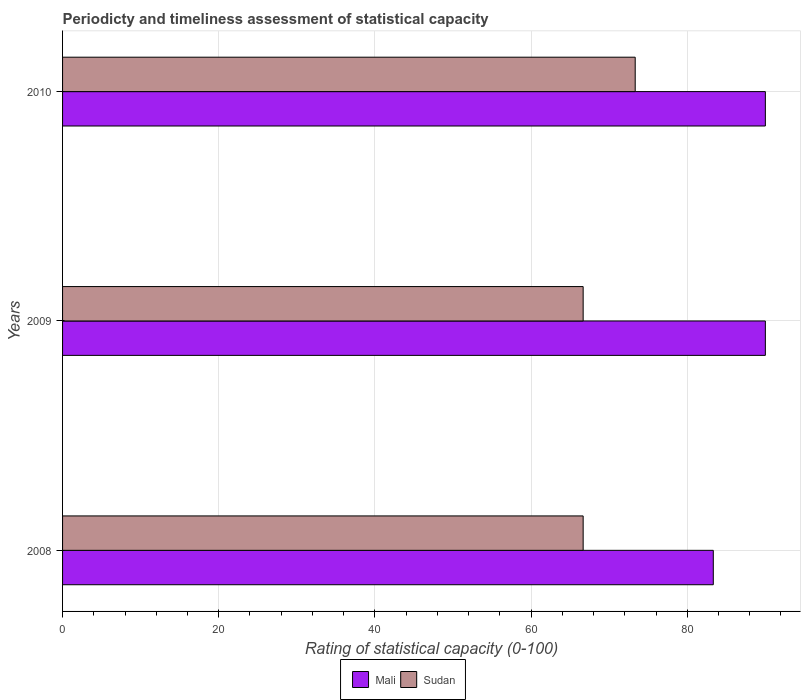How many different coloured bars are there?
Provide a succinct answer. 2. How many groups of bars are there?
Your response must be concise. 3. Are the number of bars per tick equal to the number of legend labels?
Your answer should be very brief. Yes. How many bars are there on the 3rd tick from the top?
Provide a succinct answer. 2. How many bars are there on the 2nd tick from the bottom?
Your response must be concise. 2. What is the label of the 3rd group of bars from the top?
Your response must be concise. 2008. What is the rating of statistical capacity in Sudan in 2010?
Ensure brevity in your answer.  73.33. Across all years, what is the maximum rating of statistical capacity in Sudan?
Ensure brevity in your answer.  73.33. Across all years, what is the minimum rating of statistical capacity in Mali?
Give a very brief answer. 83.33. In which year was the rating of statistical capacity in Sudan maximum?
Your response must be concise. 2010. What is the total rating of statistical capacity in Sudan in the graph?
Make the answer very short. 206.67. What is the difference between the rating of statistical capacity in Sudan in 2008 and that in 2009?
Offer a terse response. 0. What is the difference between the rating of statistical capacity in Mali in 2010 and the rating of statistical capacity in Sudan in 2008?
Provide a short and direct response. 23.33. What is the average rating of statistical capacity in Mali per year?
Keep it short and to the point. 87.78. In the year 2008, what is the difference between the rating of statistical capacity in Sudan and rating of statistical capacity in Mali?
Give a very brief answer. -16.67. Is the rating of statistical capacity in Mali in 2008 less than that in 2010?
Your answer should be compact. Yes. What is the difference between the highest and the second highest rating of statistical capacity in Mali?
Give a very brief answer. 0. What is the difference between the highest and the lowest rating of statistical capacity in Sudan?
Make the answer very short. 6.67. In how many years, is the rating of statistical capacity in Mali greater than the average rating of statistical capacity in Mali taken over all years?
Offer a very short reply. 2. What does the 2nd bar from the top in 2010 represents?
Your answer should be compact. Mali. What does the 2nd bar from the bottom in 2008 represents?
Offer a very short reply. Sudan. Are all the bars in the graph horizontal?
Offer a terse response. Yes. How many years are there in the graph?
Offer a terse response. 3. What is the difference between two consecutive major ticks on the X-axis?
Offer a terse response. 20. Does the graph contain any zero values?
Your response must be concise. No. Where does the legend appear in the graph?
Offer a terse response. Bottom center. What is the title of the graph?
Give a very brief answer. Periodicty and timeliness assessment of statistical capacity. Does "Gambia, The" appear as one of the legend labels in the graph?
Make the answer very short. No. What is the label or title of the X-axis?
Make the answer very short. Rating of statistical capacity (0-100). What is the label or title of the Y-axis?
Provide a succinct answer. Years. What is the Rating of statistical capacity (0-100) of Mali in 2008?
Ensure brevity in your answer.  83.33. What is the Rating of statistical capacity (0-100) of Sudan in 2008?
Your response must be concise. 66.67. What is the Rating of statistical capacity (0-100) of Sudan in 2009?
Offer a very short reply. 66.67. What is the Rating of statistical capacity (0-100) in Mali in 2010?
Your answer should be very brief. 90. What is the Rating of statistical capacity (0-100) of Sudan in 2010?
Offer a very short reply. 73.33. Across all years, what is the maximum Rating of statistical capacity (0-100) of Mali?
Make the answer very short. 90. Across all years, what is the maximum Rating of statistical capacity (0-100) in Sudan?
Keep it short and to the point. 73.33. Across all years, what is the minimum Rating of statistical capacity (0-100) of Mali?
Your response must be concise. 83.33. Across all years, what is the minimum Rating of statistical capacity (0-100) in Sudan?
Keep it short and to the point. 66.67. What is the total Rating of statistical capacity (0-100) of Mali in the graph?
Offer a very short reply. 263.33. What is the total Rating of statistical capacity (0-100) of Sudan in the graph?
Offer a terse response. 206.67. What is the difference between the Rating of statistical capacity (0-100) of Mali in 2008 and that in 2009?
Offer a terse response. -6.67. What is the difference between the Rating of statistical capacity (0-100) in Sudan in 2008 and that in 2009?
Offer a terse response. 0. What is the difference between the Rating of statistical capacity (0-100) of Mali in 2008 and that in 2010?
Keep it short and to the point. -6.67. What is the difference between the Rating of statistical capacity (0-100) in Sudan in 2008 and that in 2010?
Offer a terse response. -6.67. What is the difference between the Rating of statistical capacity (0-100) of Mali in 2009 and that in 2010?
Provide a short and direct response. 0. What is the difference between the Rating of statistical capacity (0-100) in Sudan in 2009 and that in 2010?
Ensure brevity in your answer.  -6.67. What is the difference between the Rating of statistical capacity (0-100) of Mali in 2008 and the Rating of statistical capacity (0-100) of Sudan in 2009?
Make the answer very short. 16.67. What is the difference between the Rating of statistical capacity (0-100) of Mali in 2008 and the Rating of statistical capacity (0-100) of Sudan in 2010?
Provide a short and direct response. 10. What is the difference between the Rating of statistical capacity (0-100) of Mali in 2009 and the Rating of statistical capacity (0-100) of Sudan in 2010?
Your answer should be compact. 16.67. What is the average Rating of statistical capacity (0-100) in Mali per year?
Give a very brief answer. 87.78. What is the average Rating of statistical capacity (0-100) of Sudan per year?
Your answer should be compact. 68.89. In the year 2008, what is the difference between the Rating of statistical capacity (0-100) in Mali and Rating of statistical capacity (0-100) in Sudan?
Provide a succinct answer. 16.67. In the year 2009, what is the difference between the Rating of statistical capacity (0-100) of Mali and Rating of statistical capacity (0-100) of Sudan?
Keep it short and to the point. 23.33. In the year 2010, what is the difference between the Rating of statistical capacity (0-100) in Mali and Rating of statistical capacity (0-100) in Sudan?
Offer a very short reply. 16.67. What is the ratio of the Rating of statistical capacity (0-100) in Mali in 2008 to that in 2009?
Your response must be concise. 0.93. What is the ratio of the Rating of statistical capacity (0-100) in Sudan in 2008 to that in 2009?
Ensure brevity in your answer.  1. What is the ratio of the Rating of statistical capacity (0-100) of Mali in 2008 to that in 2010?
Your answer should be very brief. 0.93. What is the ratio of the Rating of statistical capacity (0-100) of Sudan in 2008 to that in 2010?
Keep it short and to the point. 0.91. What is the difference between the highest and the second highest Rating of statistical capacity (0-100) in Mali?
Offer a terse response. 0. What is the difference between the highest and the lowest Rating of statistical capacity (0-100) of Mali?
Your answer should be very brief. 6.67. What is the difference between the highest and the lowest Rating of statistical capacity (0-100) of Sudan?
Provide a short and direct response. 6.67. 